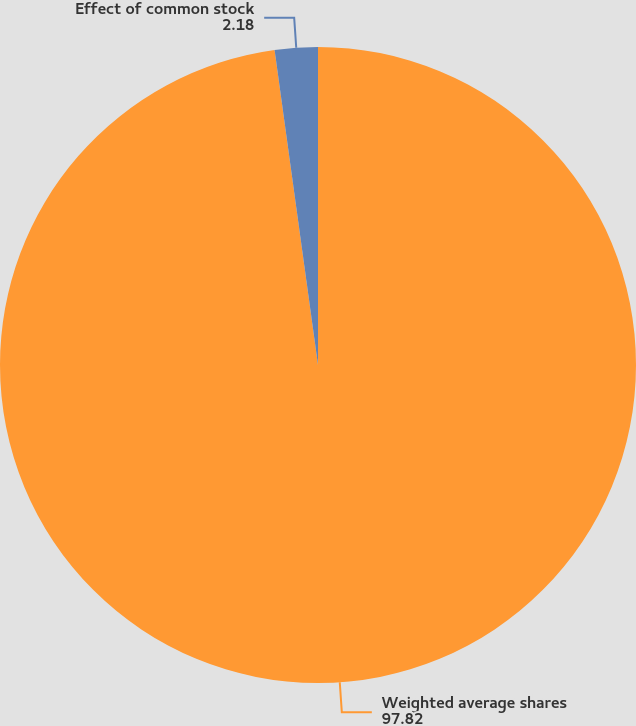Convert chart. <chart><loc_0><loc_0><loc_500><loc_500><pie_chart><fcel>Weighted average shares<fcel>Effect of common stock<nl><fcel>97.82%<fcel>2.18%<nl></chart> 